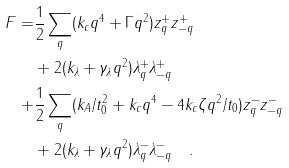Convert formula to latex. <formula><loc_0><loc_0><loc_500><loc_500>F = & \frac { 1 } { 2 } \sum _ { q } ( k _ { c } q ^ { 4 } + \Gamma q ^ { 2 } ) z _ { q } ^ { + } z _ { - q } ^ { + } \\ & + 2 ( k _ { \lambda } + \gamma _ { \lambda } q ^ { 2 } ) \lambda _ { q } ^ { + } \lambda _ { - q } ^ { + } \\ + & \frac { 1 } { 2 } \sum _ { q } ( k _ { A } / t _ { 0 } ^ { 2 } + k _ { c } q ^ { 4 } - 4 k _ { c } \zeta q ^ { 2 } / t _ { 0 } ) z _ { q } ^ { - } z _ { - q } ^ { - } \\ & + 2 ( k _ { \lambda } + \gamma _ { \lambda } q ^ { 2 } ) \lambda _ { q } ^ { - } \lambda _ { - q } ^ { - } \quad .</formula> 